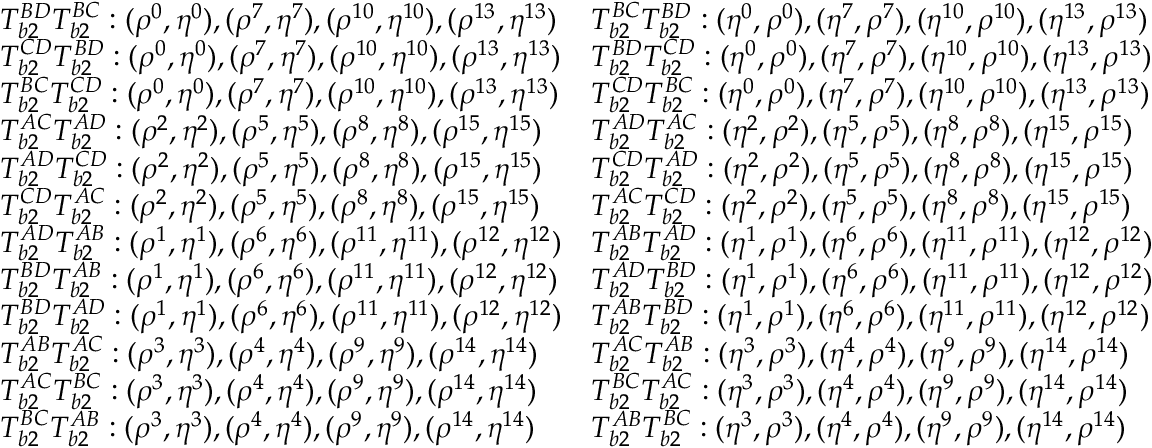<formula> <loc_0><loc_0><loc_500><loc_500>\begin{array} { l l } { T _ { b 2 } ^ { B D } T _ { b 2 } ^ { B C } \colon ( \rho ^ { 0 } , \eta ^ { 0 } ) , ( \rho ^ { 7 } , \eta ^ { 7 } ) , ( \rho ^ { 1 0 } , \eta ^ { 1 0 } ) , ( \rho ^ { 1 3 } , \eta ^ { 1 3 } ) } & { T _ { b 2 } ^ { B C } T _ { b 2 } ^ { B D } \colon ( \eta ^ { 0 } , \rho ^ { 0 } ) , ( \eta ^ { 7 } , \rho ^ { 7 } ) , ( \eta ^ { 1 0 } , \rho ^ { 1 0 } ) , ( \eta ^ { 1 3 } , \rho ^ { 1 3 } ) } \\ { T _ { b 2 } ^ { C D } T _ { b 2 } ^ { B D } \colon ( \rho ^ { 0 } , \eta ^ { 0 } ) , ( \rho ^ { 7 } , \eta ^ { 7 } ) , ( \rho ^ { 1 0 } , \eta ^ { 1 0 } ) , ( \rho ^ { 1 3 } , \eta ^ { 1 3 } ) } & { T _ { b 2 } ^ { B D } T _ { b 2 } ^ { C D } \colon ( \eta ^ { 0 } , \rho ^ { 0 } ) , ( \eta ^ { 7 } , \rho ^ { 7 } ) , ( \eta ^ { 1 0 } , \rho ^ { 1 0 } ) , ( \eta ^ { 1 3 } , \rho ^ { 1 3 } ) } \\ { T _ { b 2 } ^ { B C } T _ { b 2 } ^ { C D } \colon ( \rho ^ { 0 } , \eta ^ { 0 } ) , ( \rho ^ { 7 } , \eta ^ { 7 } ) , ( \rho ^ { 1 0 } , \eta ^ { 1 0 } ) , ( \rho ^ { 1 3 } , \eta ^ { 1 3 } ) } & { T _ { b 2 } ^ { C D } T _ { b 2 } ^ { B C } \colon ( \eta ^ { 0 } , \rho ^ { 0 } ) , ( \eta ^ { 7 } , \rho ^ { 7 } ) , ( \eta ^ { 1 0 } , \rho ^ { 1 0 } ) , ( \eta ^ { 1 3 } , \rho ^ { 1 3 } ) } \\ { T _ { b 2 } ^ { A C } T _ { b 2 } ^ { A D } \colon ( \rho ^ { 2 } , \eta ^ { 2 } ) , ( \rho ^ { 5 } , \eta ^ { 5 } ) , ( \rho ^ { 8 } , \eta ^ { 8 } ) , ( \rho ^ { 1 5 } , \eta ^ { 1 5 } ) } & { T _ { b 2 } ^ { A D } T _ { b 2 } ^ { A C } \colon ( \eta ^ { 2 } , \rho ^ { 2 } ) , ( \eta ^ { 5 } , \rho ^ { 5 } ) , ( \eta ^ { 8 } , \rho ^ { 8 } ) , ( \eta ^ { 1 5 } , \rho ^ { 1 5 } ) } \\ { T _ { b 2 } ^ { A D } T _ { b 2 } ^ { C D } \colon ( \rho ^ { 2 } , \eta ^ { 2 } ) , ( \rho ^ { 5 } , \eta ^ { 5 } ) , ( \rho ^ { 8 } , \eta ^ { 8 } ) , ( \rho ^ { 1 5 } , \eta ^ { 1 5 } ) } & { T _ { b 2 } ^ { C D } T _ { b 2 } ^ { A D } \colon ( \eta ^ { 2 } , \rho ^ { 2 } ) , ( \eta ^ { 5 } , \rho ^ { 5 } ) , ( \eta ^ { 8 } , \rho ^ { 8 } ) , ( \eta ^ { 1 5 } , \rho ^ { 1 5 } ) } \\ { T _ { b 2 } ^ { C D } T _ { b 2 } ^ { A C } \colon ( \rho ^ { 2 } , \eta ^ { 2 } ) , ( \rho ^ { 5 } , \eta ^ { 5 } ) , ( \rho ^ { 8 } , \eta ^ { 8 } ) , ( \rho ^ { 1 5 } , \eta ^ { 1 5 } ) } & { T _ { b 2 } ^ { A C } T _ { b 2 } ^ { C D } \colon ( \eta ^ { 2 } , \rho ^ { 2 } ) , ( \eta ^ { 5 } , \rho ^ { 5 } ) , ( \eta ^ { 8 } , \rho ^ { 8 } ) , ( \eta ^ { 1 5 } , \rho ^ { 1 5 } ) } \\ { T _ { b 2 } ^ { A D } T _ { b 2 } ^ { A B } \colon ( \rho ^ { 1 } , \eta ^ { 1 } ) , ( \rho ^ { 6 } , \eta ^ { 6 } ) , ( \rho ^ { 1 1 } , \eta ^ { 1 1 } ) , ( \rho ^ { 1 2 } , \eta ^ { 1 2 } ) } & { T _ { b 2 } ^ { A B } T _ { b 2 } ^ { A D } \colon ( \eta ^ { 1 } , \rho ^ { 1 } ) , ( \eta ^ { 6 } , \rho ^ { 6 } ) , ( \eta ^ { 1 1 } , \rho ^ { 1 1 } ) , ( \eta ^ { 1 2 } , \rho ^ { 1 2 } ) } \\ { T _ { b 2 } ^ { B D } T _ { b 2 } ^ { A B } \colon ( \rho ^ { 1 } , \eta ^ { 1 } ) , ( \rho ^ { 6 } , \eta ^ { 6 } ) , ( \rho ^ { 1 1 } , \eta ^ { 1 1 } ) , ( \rho ^ { 1 2 } , \eta ^ { 1 2 } ) } & { T _ { b 2 } ^ { A D } T _ { b 2 } ^ { B D } \colon ( \eta ^ { 1 } , \rho ^ { 1 } ) , ( \eta ^ { 6 } , \rho ^ { 6 } ) , ( \eta ^ { 1 1 } , \rho ^ { 1 1 } ) , ( \eta ^ { 1 2 } , \rho ^ { 1 2 } ) } \\ { T _ { b 2 } ^ { B D } T _ { b 2 } ^ { A D } \colon ( \rho ^ { 1 } , \eta ^ { 1 } ) , ( \rho ^ { 6 } , \eta ^ { 6 } ) , ( \rho ^ { 1 1 } , \eta ^ { 1 1 } ) , ( \rho ^ { 1 2 } , \eta ^ { 1 2 } ) } & { T _ { b 2 } ^ { A B } T _ { b 2 } ^ { B D } \colon ( \eta ^ { 1 } , \rho ^ { 1 } ) , ( \eta ^ { 6 } , \rho ^ { 6 } ) , ( \eta ^ { 1 1 } , \rho ^ { 1 1 } ) , ( \eta ^ { 1 2 } , \rho ^ { 1 2 } ) } \\ { T _ { b 2 } ^ { A B } T _ { b 2 } ^ { A C } \colon ( \rho ^ { 3 } , \eta ^ { 3 } ) , ( \rho ^ { 4 } , \eta ^ { 4 } ) , ( \rho ^ { 9 } , \eta ^ { 9 } ) , ( \rho ^ { 1 4 } , \eta ^ { 1 4 } ) } & { T _ { b 2 } ^ { A C } T _ { b 2 } ^ { A B } \colon ( \eta ^ { 3 } , \rho ^ { 3 } ) , ( \eta ^ { 4 } , \rho ^ { 4 } ) , ( \eta ^ { 9 } , \rho ^ { 9 } ) , ( \eta ^ { 1 4 } , \rho ^ { 1 4 } ) } \\ { T _ { b 2 } ^ { A C } T _ { b 2 } ^ { B C } \colon ( \rho ^ { 3 } , \eta ^ { 3 } ) , ( \rho ^ { 4 } , \eta ^ { 4 } ) , ( \rho ^ { 9 } , \eta ^ { 9 } ) , ( \rho ^ { 1 4 } , \eta ^ { 1 4 } ) } & { T _ { b 2 } ^ { B C } T _ { b 2 } ^ { A C } \colon ( \eta ^ { 3 } , \rho ^ { 3 } ) , ( \eta ^ { 4 } , \rho ^ { 4 } ) , ( \eta ^ { 9 } , \rho ^ { 9 } ) , ( \eta ^ { 1 4 } , \rho ^ { 1 4 } ) } \\ { T _ { b 2 } ^ { B C } T _ { b 2 } ^ { A B } \colon ( \rho ^ { 3 } , \eta ^ { 3 } ) , ( \rho ^ { 4 } , \eta ^ { 4 } ) , ( \rho ^ { 9 } , \eta ^ { 9 } ) , ( \rho ^ { 1 4 } , \eta ^ { 1 4 } ) } & { T _ { b 2 } ^ { A B } T _ { b 2 } ^ { B C } \colon ( \eta ^ { 3 } , \rho ^ { 3 } ) , ( \eta ^ { 4 } , \rho ^ { 4 } ) , ( \eta ^ { 9 } , \rho ^ { 9 } ) , ( \eta ^ { 1 4 } , \rho ^ { 1 4 } ) } \end{array}</formula> 